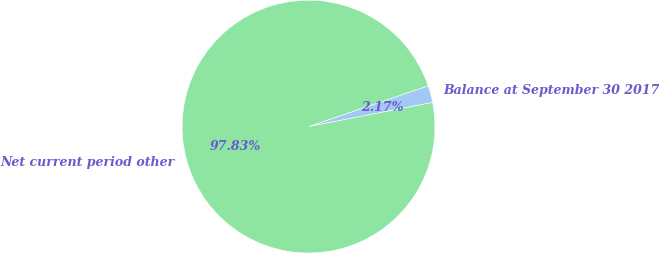<chart> <loc_0><loc_0><loc_500><loc_500><pie_chart><fcel>Balance at September 30 2017<fcel>Net current period other<nl><fcel>2.17%<fcel>97.83%<nl></chart> 